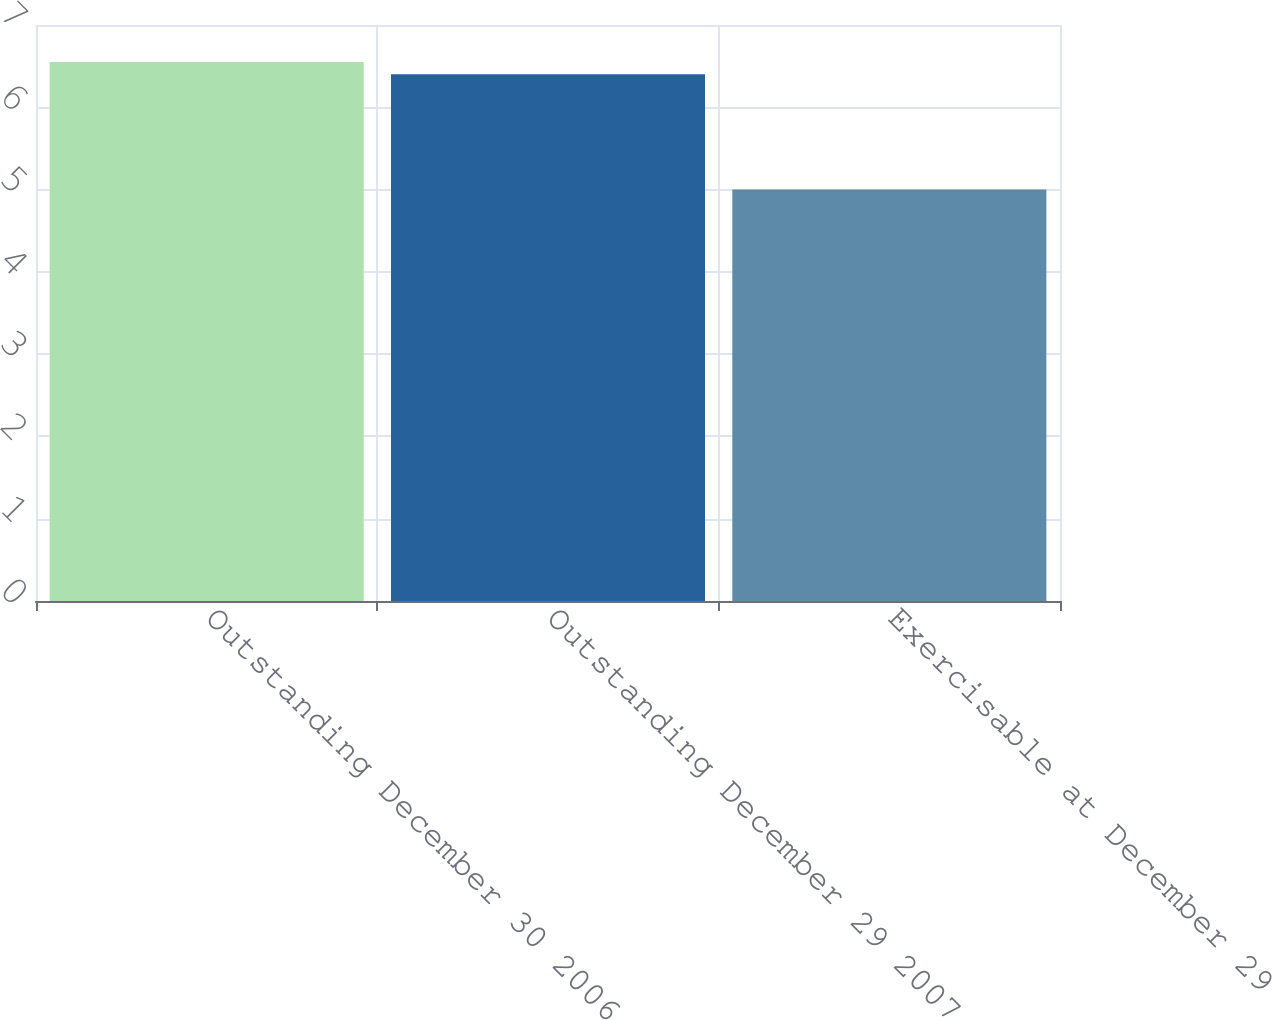<chart> <loc_0><loc_0><loc_500><loc_500><bar_chart><fcel>Outstanding December 30 2006<fcel>Outstanding December 29 2007<fcel>Exercisable at December 29<nl><fcel>6.55<fcel>6.4<fcel>5<nl></chart> 